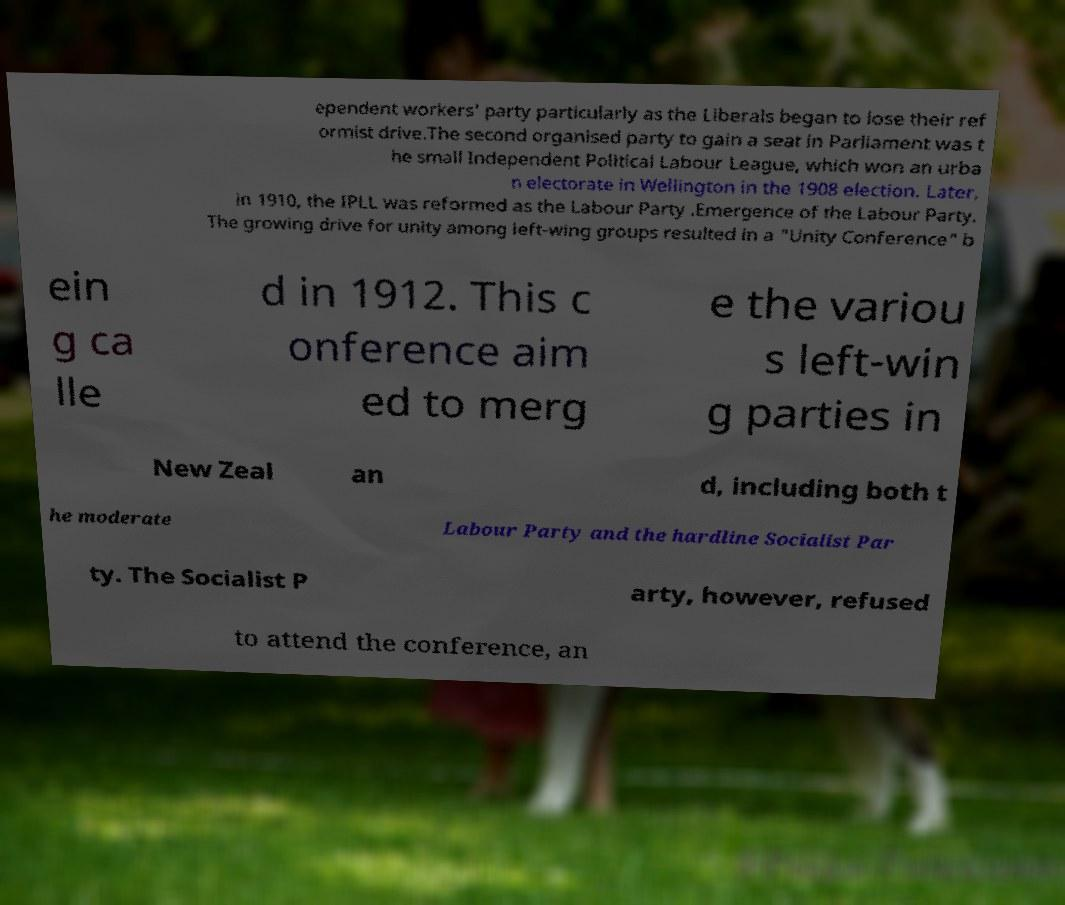What messages or text are displayed in this image? I need them in a readable, typed format. ependent workers' party particularly as the Liberals began to lose their ref ormist drive.The second organised party to gain a seat in Parliament was t he small Independent Political Labour League, which won an urba n electorate in Wellington in the 1908 election. Later, in 1910, the IPLL was reformed as the Labour Party .Emergence of the Labour Party. The growing drive for unity among left-wing groups resulted in a "Unity Conference" b ein g ca lle d in 1912. This c onference aim ed to merg e the variou s left-win g parties in New Zeal an d, including both t he moderate Labour Party and the hardline Socialist Par ty. The Socialist P arty, however, refused to attend the conference, an 